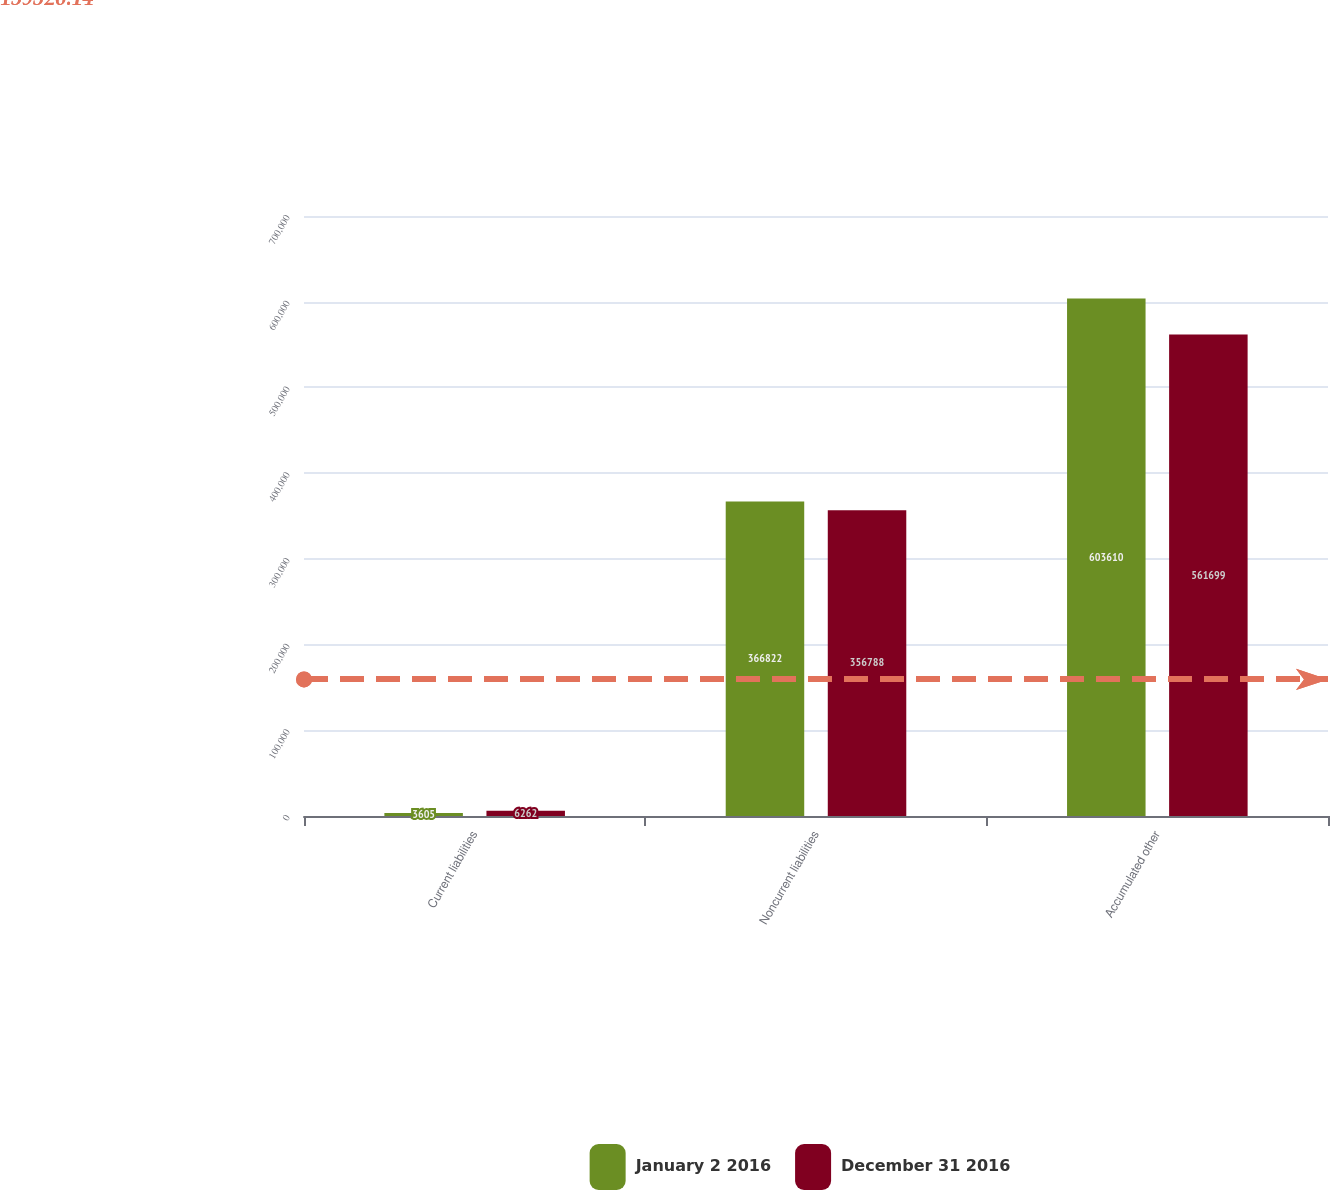<chart> <loc_0><loc_0><loc_500><loc_500><stacked_bar_chart><ecel><fcel>Current liabilities<fcel>Noncurrent liabilities<fcel>Accumulated other<nl><fcel>January 2 2016<fcel>3605<fcel>366822<fcel>603610<nl><fcel>December 31 2016<fcel>6262<fcel>356788<fcel>561699<nl></chart> 